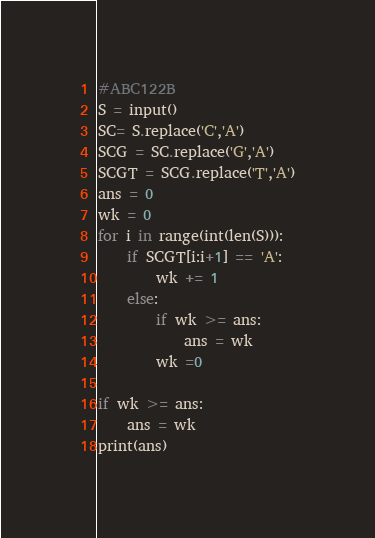<code> <loc_0><loc_0><loc_500><loc_500><_Python_>#ABC122B
S = input()
SC= S.replace('C','A')
SCG = SC.replace('G','A')
SCGT = SCG.replace('T','A')
ans = 0
wk = 0
for i in range(int(len(S))):
    if SCGT[i:i+1] == 'A':
        wk += 1
    else:
        if wk >= ans:
            ans = wk
        wk =0

if wk >= ans:
    ans = wk
print(ans)</code> 